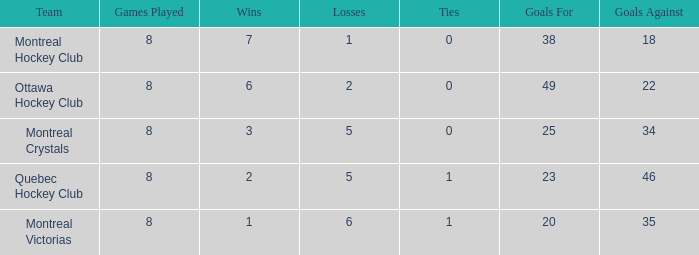What is the total number of goals for when the ties is more than 0, the goals against is more than 35 and the wins is less than 2? 0.0. 